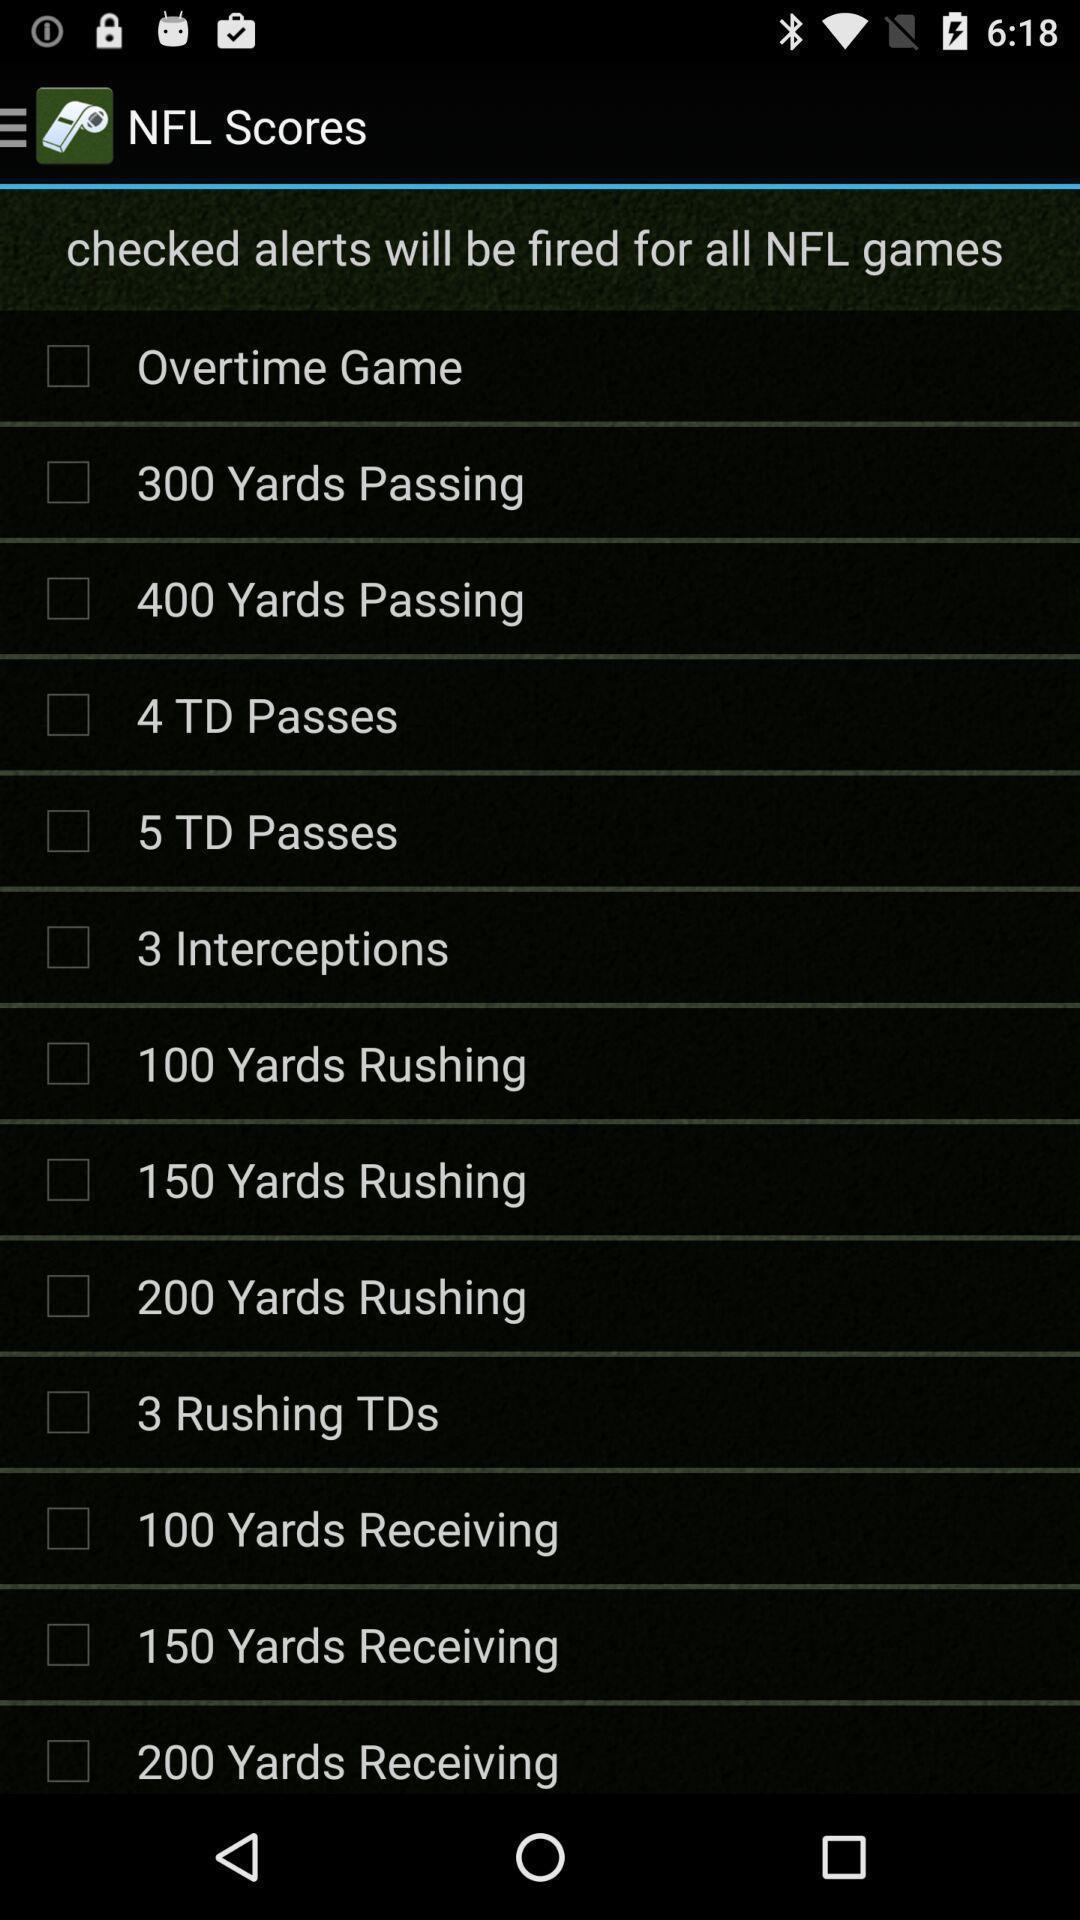Tell me about the visual elements in this screen capture. Screen display scorecard of a gaming app. 